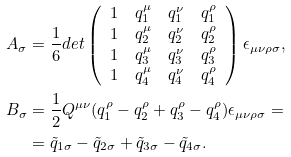<formula> <loc_0><loc_0><loc_500><loc_500>A _ { \sigma } & = \frac { 1 } { 6 } d e t \left ( \begin{array} { c c c c } 1 & q _ { 1 } ^ { \mu } & q _ { 1 } ^ { \nu } & q _ { 1 } ^ { \rho } \\ 1 & q _ { 2 } ^ { \mu } & q _ { 2 } ^ { \nu } & q _ { 2 } ^ { \rho } \\ 1 & q _ { 3 } ^ { \mu } & q _ { 3 } ^ { \nu } & q _ { 3 } ^ { \rho } \\ 1 & q _ { 4 } ^ { \mu } & q _ { 4 } ^ { \nu } & q _ { 4 } ^ { \rho } \\ \end{array} \right ) \epsilon _ { \mu \nu \rho \sigma } , \\ B _ { \sigma } & = \frac { 1 } { 2 } Q ^ { \mu \nu } ( q _ { 1 } ^ { \rho } - q _ { 2 } ^ { \rho } + q _ { 3 } ^ { \rho } - q _ { 4 } ^ { \rho } ) \epsilon _ { \mu \nu \rho \sigma } = \\ & = { \tilde { q } } _ { 1 \sigma } - { \tilde { q } } _ { 2 \sigma } + { \tilde { q } } _ { 3 \sigma } - { \tilde { q } } _ { 4 \sigma } .</formula> 